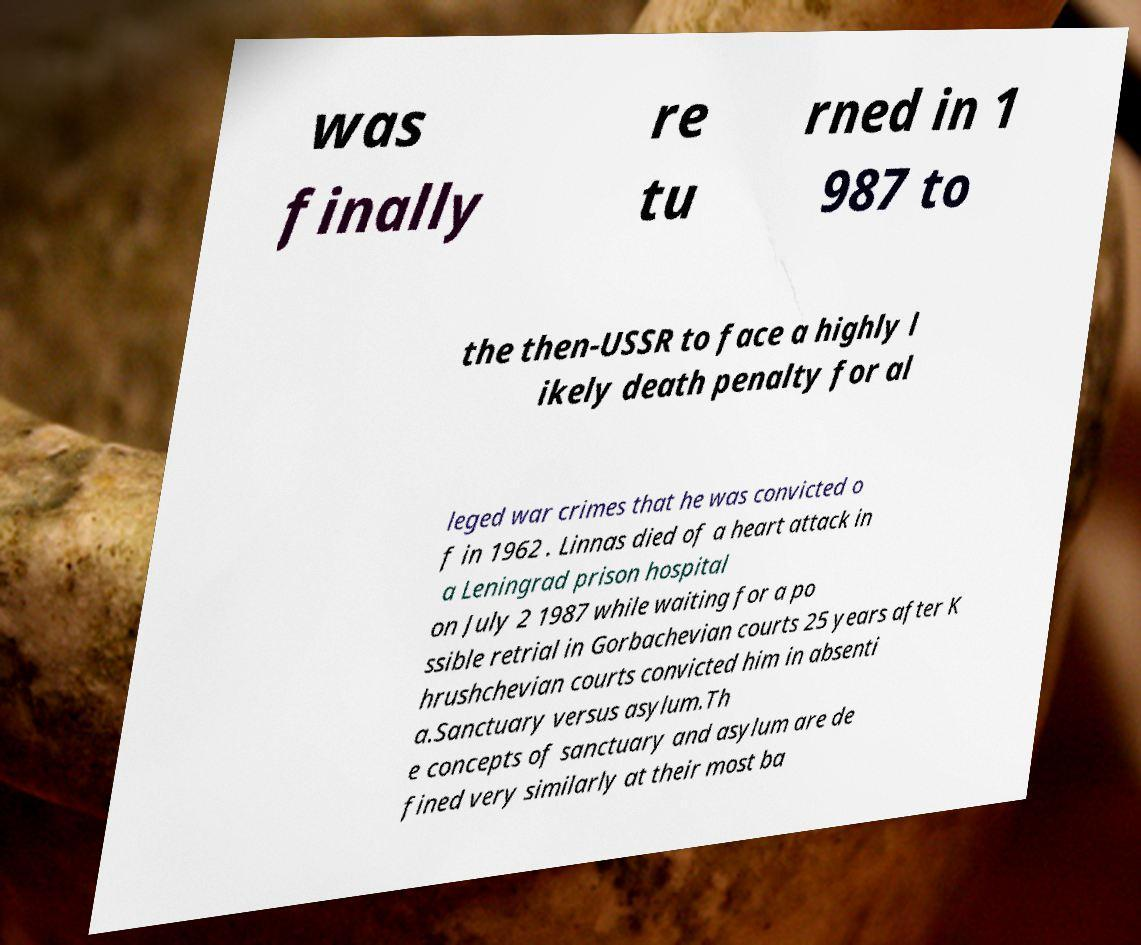What messages or text are displayed in this image? I need them in a readable, typed format. was finally re tu rned in 1 987 to the then-USSR to face a highly l ikely death penalty for al leged war crimes that he was convicted o f in 1962 . Linnas died of a heart attack in a Leningrad prison hospital on July 2 1987 while waiting for a po ssible retrial in Gorbachevian courts 25 years after K hrushchevian courts convicted him in absenti a.Sanctuary versus asylum.Th e concepts of sanctuary and asylum are de fined very similarly at their most ba 